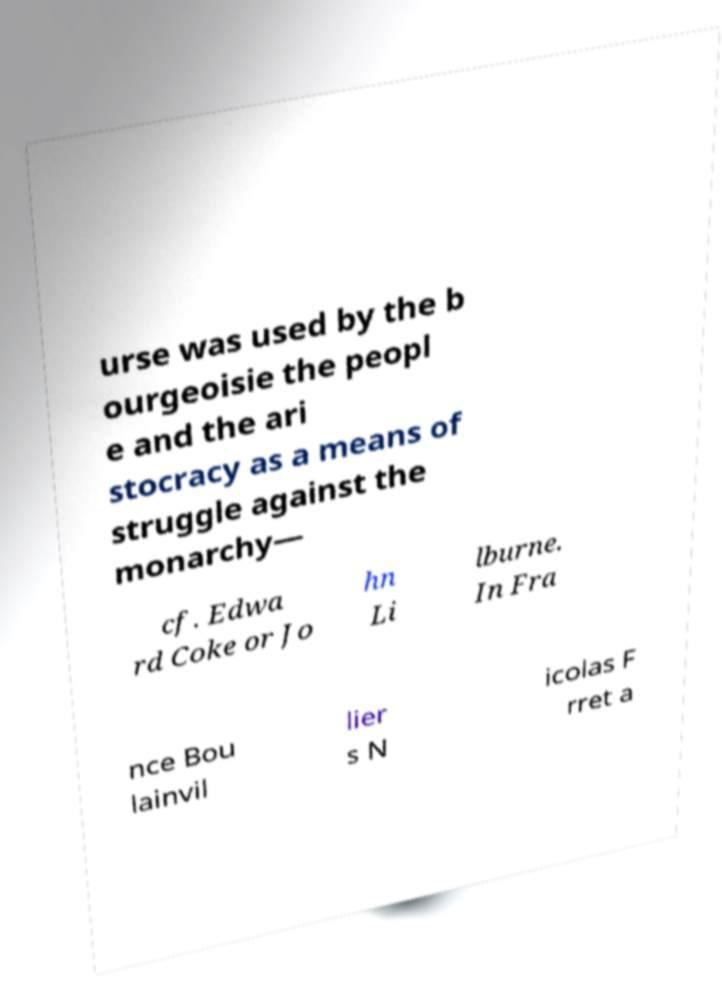Please identify and transcribe the text found in this image. urse was used by the b ourgeoisie the peopl e and the ari stocracy as a means of struggle against the monarchy— cf. Edwa rd Coke or Jo hn Li lburne. In Fra nce Bou lainvil lier s N icolas F rret a 